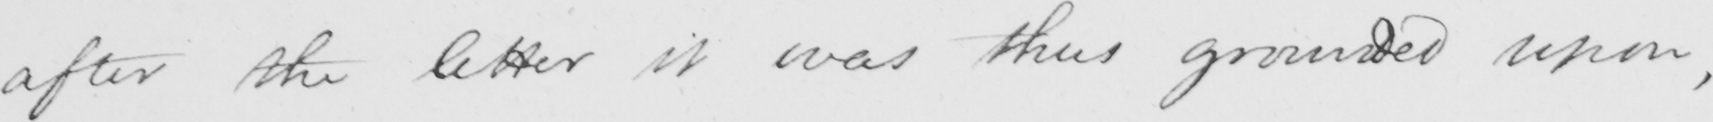Transcribe the text shown in this historical manuscript line. after the letter it was thus grounded upon , 